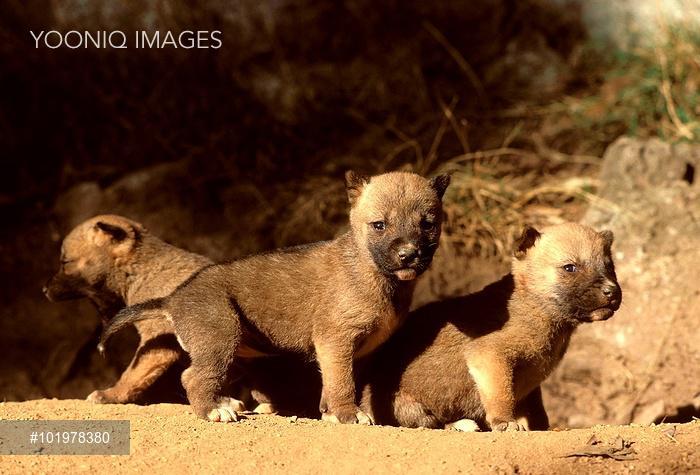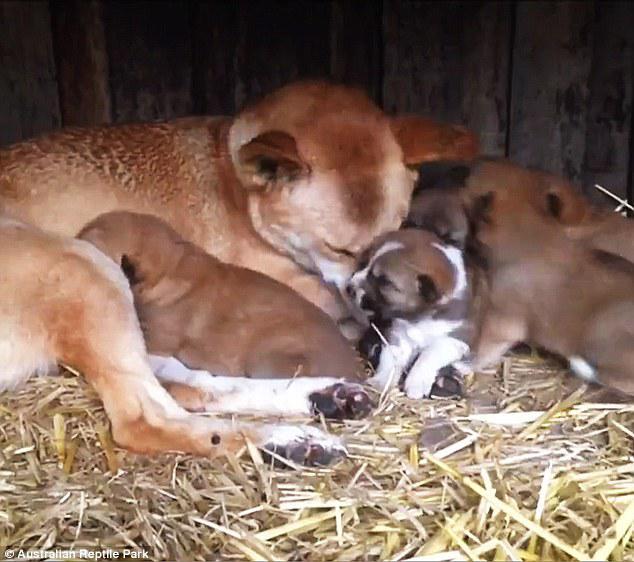The first image is the image on the left, the second image is the image on the right. For the images shown, is this caption "In the image on the right several puppies are nestled on straw." true? Answer yes or no. Yes. The first image is the image on the left, the second image is the image on the right. Examine the images to the left and right. Is the description "One image shows only multiple pups, and the other image shows a mother dog with pups." accurate? Answer yes or no. Yes. 